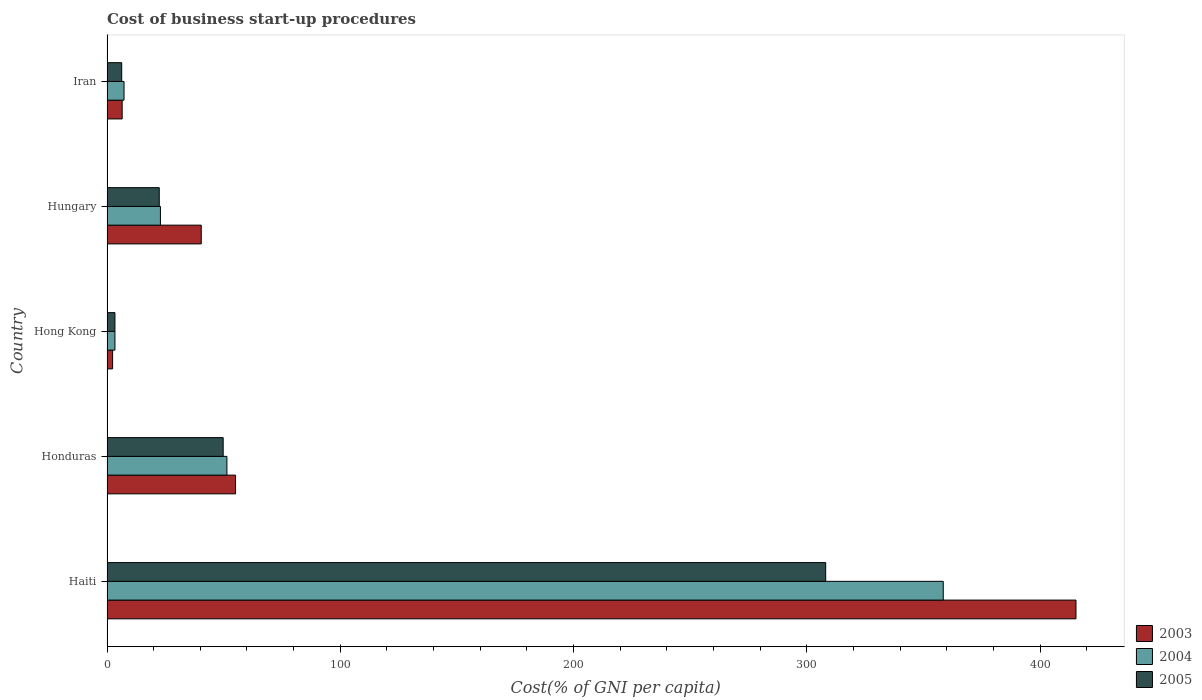How many groups of bars are there?
Offer a terse response. 5. What is the label of the 1st group of bars from the top?
Give a very brief answer. Iran. What is the cost of business start-up procedures in 2005 in Hong Kong?
Provide a short and direct response. 3.4. Across all countries, what is the maximum cost of business start-up procedures in 2004?
Provide a succinct answer. 358.5. In which country was the cost of business start-up procedures in 2004 maximum?
Your answer should be very brief. Haiti. In which country was the cost of business start-up procedures in 2003 minimum?
Your response must be concise. Hong Kong. What is the total cost of business start-up procedures in 2003 in the graph?
Provide a short and direct response. 519.8. What is the difference between the cost of business start-up procedures in 2004 in Hong Kong and that in Hungary?
Offer a terse response. -19.5. What is the difference between the cost of business start-up procedures in 2005 in Haiti and the cost of business start-up procedures in 2003 in Hungary?
Your answer should be compact. 267.7. What is the average cost of business start-up procedures in 2004 per country?
Your answer should be compact. 88.7. What is the difference between the cost of business start-up procedures in 2004 and cost of business start-up procedures in 2003 in Hungary?
Ensure brevity in your answer.  -17.5. In how many countries, is the cost of business start-up procedures in 2003 greater than 320 %?
Your answer should be compact. 1. What is the ratio of the cost of business start-up procedures in 2004 in Haiti to that in Iran?
Offer a very short reply. 49.11. Is the cost of business start-up procedures in 2003 in Hungary less than that in Iran?
Your answer should be very brief. No. Is the difference between the cost of business start-up procedures in 2004 in Hungary and Iran greater than the difference between the cost of business start-up procedures in 2003 in Hungary and Iran?
Make the answer very short. No. What is the difference between the highest and the second highest cost of business start-up procedures in 2005?
Your answer should be compact. 258.3. What is the difference between the highest and the lowest cost of business start-up procedures in 2003?
Provide a short and direct response. 413. Is the sum of the cost of business start-up procedures in 2005 in Honduras and Iran greater than the maximum cost of business start-up procedures in 2003 across all countries?
Keep it short and to the point. No. Are all the bars in the graph horizontal?
Your answer should be compact. Yes. How many countries are there in the graph?
Keep it short and to the point. 5. Does the graph contain any zero values?
Ensure brevity in your answer.  No. Does the graph contain grids?
Your answer should be compact. No. What is the title of the graph?
Provide a short and direct response. Cost of business start-up procedures. Does "1973" appear as one of the legend labels in the graph?
Your answer should be very brief. No. What is the label or title of the X-axis?
Keep it short and to the point. Cost(% of GNI per capita). What is the Cost(% of GNI per capita) of 2003 in Haiti?
Give a very brief answer. 415.4. What is the Cost(% of GNI per capita) in 2004 in Haiti?
Offer a terse response. 358.5. What is the Cost(% of GNI per capita) of 2005 in Haiti?
Ensure brevity in your answer.  308.1. What is the Cost(% of GNI per capita) of 2003 in Honduras?
Provide a short and direct response. 55.1. What is the Cost(% of GNI per capita) of 2004 in Honduras?
Provide a succinct answer. 51.4. What is the Cost(% of GNI per capita) in 2005 in Honduras?
Provide a succinct answer. 49.8. What is the Cost(% of GNI per capita) of 2003 in Hungary?
Your response must be concise. 40.4. What is the Cost(% of GNI per capita) of 2004 in Hungary?
Keep it short and to the point. 22.9. What is the Cost(% of GNI per capita) in 2005 in Hungary?
Provide a short and direct response. 22.4. What is the Cost(% of GNI per capita) in 2004 in Iran?
Keep it short and to the point. 7.3. What is the Cost(% of GNI per capita) in 2005 in Iran?
Provide a succinct answer. 6.3. Across all countries, what is the maximum Cost(% of GNI per capita) of 2003?
Offer a terse response. 415.4. Across all countries, what is the maximum Cost(% of GNI per capita) of 2004?
Keep it short and to the point. 358.5. Across all countries, what is the maximum Cost(% of GNI per capita) of 2005?
Provide a short and direct response. 308.1. Across all countries, what is the minimum Cost(% of GNI per capita) in 2004?
Give a very brief answer. 3.4. Across all countries, what is the minimum Cost(% of GNI per capita) in 2005?
Your response must be concise. 3.4. What is the total Cost(% of GNI per capita) in 2003 in the graph?
Your response must be concise. 519.8. What is the total Cost(% of GNI per capita) of 2004 in the graph?
Provide a succinct answer. 443.5. What is the total Cost(% of GNI per capita) in 2005 in the graph?
Provide a short and direct response. 390. What is the difference between the Cost(% of GNI per capita) in 2003 in Haiti and that in Honduras?
Give a very brief answer. 360.3. What is the difference between the Cost(% of GNI per capita) in 2004 in Haiti and that in Honduras?
Keep it short and to the point. 307.1. What is the difference between the Cost(% of GNI per capita) in 2005 in Haiti and that in Honduras?
Ensure brevity in your answer.  258.3. What is the difference between the Cost(% of GNI per capita) in 2003 in Haiti and that in Hong Kong?
Offer a terse response. 413. What is the difference between the Cost(% of GNI per capita) of 2004 in Haiti and that in Hong Kong?
Offer a terse response. 355.1. What is the difference between the Cost(% of GNI per capita) in 2005 in Haiti and that in Hong Kong?
Give a very brief answer. 304.7. What is the difference between the Cost(% of GNI per capita) of 2003 in Haiti and that in Hungary?
Offer a very short reply. 375. What is the difference between the Cost(% of GNI per capita) of 2004 in Haiti and that in Hungary?
Offer a terse response. 335.6. What is the difference between the Cost(% of GNI per capita) of 2005 in Haiti and that in Hungary?
Offer a very short reply. 285.7. What is the difference between the Cost(% of GNI per capita) in 2003 in Haiti and that in Iran?
Provide a short and direct response. 408.9. What is the difference between the Cost(% of GNI per capita) in 2004 in Haiti and that in Iran?
Keep it short and to the point. 351.2. What is the difference between the Cost(% of GNI per capita) of 2005 in Haiti and that in Iran?
Provide a short and direct response. 301.8. What is the difference between the Cost(% of GNI per capita) in 2003 in Honduras and that in Hong Kong?
Your answer should be very brief. 52.7. What is the difference between the Cost(% of GNI per capita) in 2004 in Honduras and that in Hong Kong?
Your response must be concise. 48. What is the difference between the Cost(% of GNI per capita) of 2005 in Honduras and that in Hong Kong?
Give a very brief answer. 46.4. What is the difference between the Cost(% of GNI per capita) of 2005 in Honduras and that in Hungary?
Ensure brevity in your answer.  27.4. What is the difference between the Cost(% of GNI per capita) in 2003 in Honduras and that in Iran?
Offer a very short reply. 48.6. What is the difference between the Cost(% of GNI per capita) of 2004 in Honduras and that in Iran?
Provide a short and direct response. 44.1. What is the difference between the Cost(% of GNI per capita) in 2005 in Honduras and that in Iran?
Offer a very short reply. 43.5. What is the difference between the Cost(% of GNI per capita) of 2003 in Hong Kong and that in Hungary?
Make the answer very short. -38. What is the difference between the Cost(% of GNI per capita) of 2004 in Hong Kong and that in Hungary?
Give a very brief answer. -19.5. What is the difference between the Cost(% of GNI per capita) in 2005 in Hong Kong and that in Hungary?
Ensure brevity in your answer.  -19. What is the difference between the Cost(% of GNI per capita) of 2003 in Hong Kong and that in Iran?
Offer a very short reply. -4.1. What is the difference between the Cost(% of GNI per capita) in 2004 in Hong Kong and that in Iran?
Provide a succinct answer. -3.9. What is the difference between the Cost(% of GNI per capita) of 2005 in Hong Kong and that in Iran?
Ensure brevity in your answer.  -2.9. What is the difference between the Cost(% of GNI per capita) in 2003 in Hungary and that in Iran?
Your answer should be very brief. 33.9. What is the difference between the Cost(% of GNI per capita) in 2004 in Hungary and that in Iran?
Provide a succinct answer. 15.6. What is the difference between the Cost(% of GNI per capita) in 2005 in Hungary and that in Iran?
Keep it short and to the point. 16.1. What is the difference between the Cost(% of GNI per capita) of 2003 in Haiti and the Cost(% of GNI per capita) of 2004 in Honduras?
Ensure brevity in your answer.  364. What is the difference between the Cost(% of GNI per capita) in 2003 in Haiti and the Cost(% of GNI per capita) in 2005 in Honduras?
Offer a terse response. 365.6. What is the difference between the Cost(% of GNI per capita) in 2004 in Haiti and the Cost(% of GNI per capita) in 2005 in Honduras?
Your answer should be compact. 308.7. What is the difference between the Cost(% of GNI per capita) in 2003 in Haiti and the Cost(% of GNI per capita) in 2004 in Hong Kong?
Keep it short and to the point. 412. What is the difference between the Cost(% of GNI per capita) in 2003 in Haiti and the Cost(% of GNI per capita) in 2005 in Hong Kong?
Your answer should be compact. 412. What is the difference between the Cost(% of GNI per capita) of 2004 in Haiti and the Cost(% of GNI per capita) of 2005 in Hong Kong?
Ensure brevity in your answer.  355.1. What is the difference between the Cost(% of GNI per capita) of 2003 in Haiti and the Cost(% of GNI per capita) of 2004 in Hungary?
Provide a short and direct response. 392.5. What is the difference between the Cost(% of GNI per capita) in 2003 in Haiti and the Cost(% of GNI per capita) in 2005 in Hungary?
Your answer should be very brief. 393. What is the difference between the Cost(% of GNI per capita) in 2004 in Haiti and the Cost(% of GNI per capita) in 2005 in Hungary?
Offer a terse response. 336.1. What is the difference between the Cost(% of GNI per capita) in 2003 in Haiti and the Cost(% of GNI per capita) in 2004 in Iran?
Your answer should be very brief. 408.1. What is the difference between the Cost(% of GNI per capita) in 2003 in Haiti and the Cost(% of GNI per capita) in 2005 in Iran?
Keep it short and to the point. 409.1. What is the difference between the Cost(% of GNI per capita) of 2004 in Haiti and the Cost(% of GNI per capita) of 2005 in Iran?
Ensure brevity in your answer.  352.2. What is the difference between the Cost(% of GNI per capita) in 2003 in Honduras and the Cost(% of GNI per capita) in 2004 in Hong Kong?
Ensure brevity in your answer.  51.7. What is the difference between the Cost(% of GNI per capita) of 2003 in Honduras and the Cost(% of GNI per capita) of 2005 in Hong Kong?
Your answer should be very brief. 51.7. What is the difference between the Cost(% of GNI per capita) in 2003 in Honduras and the Cost(% of GNI per capita) in 2004 in Hungary?
Your answer should be very brief. 32.2. What is the difference between the Cost(% of GNI per capita) in 2003 in Honduras and the Cost(% of GNI per capita) in 2005 in Hungary?
Give a very brief answer. 32.7. What is the difference between the Cost(% of GNI per capita) in 2003 in Honduras and the Cost(% of GNI per capita) in 2004 in Iran?
Your response must be concise. 47.8. What is the difference between the Cost(% of GNI per capita) in 2003 in Honduras and the Cost(% of GNI per capita) in 2005 in Iran?
Your answer should be very brief. 48.8. What is the difference between the Cost(% of GNI per capita) in 2004 in Honduras and the Cost(% of GNI per capita) in 2005 in Iran?
Provide a succinct answer. 45.1. What is the difference between the Cost(% of GNI per capita) of 2003 in Hong Kong and the Cost(% of GNI per capita) of 2004 in Hungary?
Offer a terse response. -20.5. What is the difference between the Cost(% of GNI per capita) in 2003 in Hong Kong and the Cost(% of GNI per capita) in 2005 in Hungary?
Provide a succinct answer. -20. What is the difference between the Cost(% of GNI per capita) of 2004 in Hong Kong and the Cost(% of GNI per capita) of 2005 in Hungary?
Provide a short and direct response. -19. What is the difference between the Cost(% of GNI per capita) in 2003 in Hong Kong and the Cost(% of GNI per capita) in 2004 in Iran?
Provide a succinct answer. -4.9. What is the difference between the Cost(% of GNI per capita) in 2003 in Hong Kong and the Cost(% of GNI per capita) in 2005 in Iran?
Offer a very short reply. -3.9. What is the difference between the Cost(% of GNI per capita) of 2004 in Hong Kong and the Cost(% of GNI per capita) of 2005 in Iran?
Give a very brief answer. -2.9. What is the difference between the Cost(% of GNI per capita) of 2003 in Hungary and the Cost(% of GNI per capita) of 2004 in Iran?
Provide a succinct answer. 33.1. What is the difference between the Cost(% of GNI per capita) of 2003 in Hungary and the Cost(% of GNI per capita) of 2005 in Iran?
Give a very brief answer. 34.1. What is the difference between the Cost(% of GNI per capita) of 2004 in Hungary and the Cost(% of GNI per capita) of 2005 in Iran?
Offer a very short reply. 16.6. What is the average Cost(% of GNI per capita) in 2003 per country?
Offer a very short reply. 103.96. What is the average Cost(% of GNI per capita) in 2004 per country?
Your answer should be very brief. 88.7. What is the difference between the Cost(% of GNI per capita) in 2003 and Cost(% of GNI per capita) in 2004 in Haiti?
Your answer should be very brief. 56.9. What is the difference between the Cost(% of GNI per capita) in 2003 and Cost(% of GNI per capita) in 2005 in Haiti?
Offer a very short reply. 107.3. What is the difference between the Cost(% of GNI per capita) in 2004 and Cost(% of GNI per capita) in 2005 in Haiti?
Give a very brief answer. 50.4. What is the difference between the Cost(% of GNI per capita) of 2003 and Cost(% of GNI per capita) of 2004 in Honduras?
Provide a short and direct response. 3.7. What is the difference between the Cost(% of GNI per capita) of 2004 and Cost(% of GNI per capita) of 2005 in Honduras?
Make the answer very short. 1.6. What is the difference between the Cost(% of GNI per capita) of 2003 and Cost(% of GNI per capita) of 2004 in Hong Kong?
Your answer should be compact. -1. What is the difference between the Cost(% of GNI per capita) of 2003 and Cost(% of GNI per capita) of 2005 in Hong Kong?
Ensure brevity in your answer.  -1. What is the difference between the Cost(% of GNI per capita) of 2003 and Cost(% of GNI per capita) of 2004 in Hungary?
Ensure brevity in your answer.  17.5. What is the difference between the Cost(% of GNI per capita) in 2003 and Cost(% of GNI per capita) in 2005 in Hungary?
Provide a succinct answer. 18. What is the difference between the Cost(% of GNI per capita) in 2004 and Cost(% of GNI per capita) in 2005 in Hungary?
Ensure brevity in your answer.  0.5. What is the ratio of the Cost(% of GNI per capita) of 2003 in Haiti to that in Honduras?
Offer a terse response. 7.54. What is the ratio of the Cost(% of GNI per capita) in 2004 in Haiti to that in Honduras?
Give a very brief answer. 6.97. What is the ratio of the Cost(% of GNI per capita) in 2005 in Haiti to that in Honduras?
Offer a very short reply. 6.19. What is the ratio of the Cost(% of GNI per capita) of 2003 in Haiti to that in Hong Kong?
Make the answer very short. 173.08. What is the ratio of the Cost(% of GNI per capita) of 2004 in Haiti to that in Hong Kong?
Provide a short and direct response. 105.44. What is the ratio of the Cost(% of GNI per capita) of 2005 in Haiti to that in Hong Kong?
Keep it short and to the point. 90.62. What is the ratio of the Cost(% of GNI per capita) of 2003 in Haiti to that in Hungary?
Your answer should be compact. 10.28. What is the ratio of the Cost(% of GNI per capita) in 2004 in Haiti to that in Hungary?
Make the answer very short. 15.65. What is the ratio of the Cost(% of GNI per capita) of 2005 in Haiti to that in Hungary?
Offer a terse response. 13.75. What is the ratio of the Cost(% of GNI per capita) in 2003 in Haiti to that in Iran?
Your response must be concise. 63.91. What is the ratio of the Cost(% of GNI per capita) of 2004 in Haiti to that in Iran?
Your response must be concise. 49.11. What is the ratio of the Cost(% of GNI per capita) in 2005 in Haiti to that in Iran?
Make the answer very short. 48.9. What is the ratio of the Cost(% of GNI per capita) in 2003 in Honduras to that in Hong Kong?
Ensure brevity in your answer.  22.96. What is the ratio of the Cost(% of GNI per capita) of 2004 in Honduras to that in Hong Kong?
Your response must be concise. 15.12. What is the ratio of the Cost(% of GNI per capita) of 2005 in Honduras to that in Hong Kong?
Offer a terse response. 14.65. What is the ratio of the Cost(% of GNI per capita) of 2003 in Honduras to that in Hungary?
Your answer should be very brief. 1.36. What is the ratio of the Cost(% of GNI per capita) in 2004 in Honduras to that in Hungary?
Your answer should be compact. 2.24. What is the ratio of the Cost(% of GNI per capita) of 2005 in Honduras to that in Hungary?
Your response must be concise. 2.22. What is the ratio of the Cost(% of GNI per capita) in 2003 in Honduras to that in Iran?
Offer a terse response. 8.48. What is the ratio of the Cost(% of GNI per capita) of 2004 in Honduras to that in Iran?
Offer a terse response. 7.04. What is the ratio of the Cost(% of GNI per capita) of 2005 in Honduras to that in Iran?
Keep it short and to the point. 7.9. What is the ratio of the Cost(% of GNI per capita) in 2003 in Hong Kong to that in Hungary?
Make the answer very short. 0.06. What is the ratio of the Cost(% of GNI per capita) in 2004 in Hong Kong to that in Hungary?
Ensure brevity in your answer.  0.15. What is the ratio of the Cost(% of GNI per capita) in 2005 in Hong Kong to that in Hungary?
Offer a terse response. 0.15. What is the ratio of the Cost(% of GNI per capita) of 2003 in Hong Kong to that in Iran?
Make the answer very short. 0.37. What is the ratio of the Cost(% of GNI per capita) in 2004 in Hong Kong to that in Iran?
Your answer should be very brief. 0.47. What is the ratio of the Cost(% of GNI per capita) in 2005 in Hong Kong to that in Iran?
Provide a succinct answer. 0.54. What is the ratio of the Cost(% of GNI per capita) in 2003 in Hungary to that in Iran?
Ensure brevity in your answer.  6.22. What is the ratio of the Cost(% of GNI per capita) in 2004 in Hungary to that in Iran?
Make the answer very short. 3.14. What is the ratio of the Cost(% of GNI per capita) in 2005 in Hungary to that in Iran?
Provide a succinct answer. 3.56. What is the difference between the highest and the second highest Cost(% of GNI per capita) in 2003?
Keep it short and to the point. 360.3. What is the difference between the highest and the second highest Cost(% of GNI per capita) in 2004?
Your answer should be very brief. 307.1. What is the difference between the highest and the second highest Cost(% of GNI per capita) of 2005?
Ensure brevity in your answer.  258.3. What is the difference between the highest and the lowest Cost(% of GNI per capita) of 2003?
Offer a very short reply. 413. What is the difference between the highest and the lowest Cost(% of GNI per capita) in 2004?
Ensure brevity in your answer.  355.1. What is the difference between the highest and the lowest Cost(% of GNI per capita) of 2005?
Offer a very short reply. 304.7. 